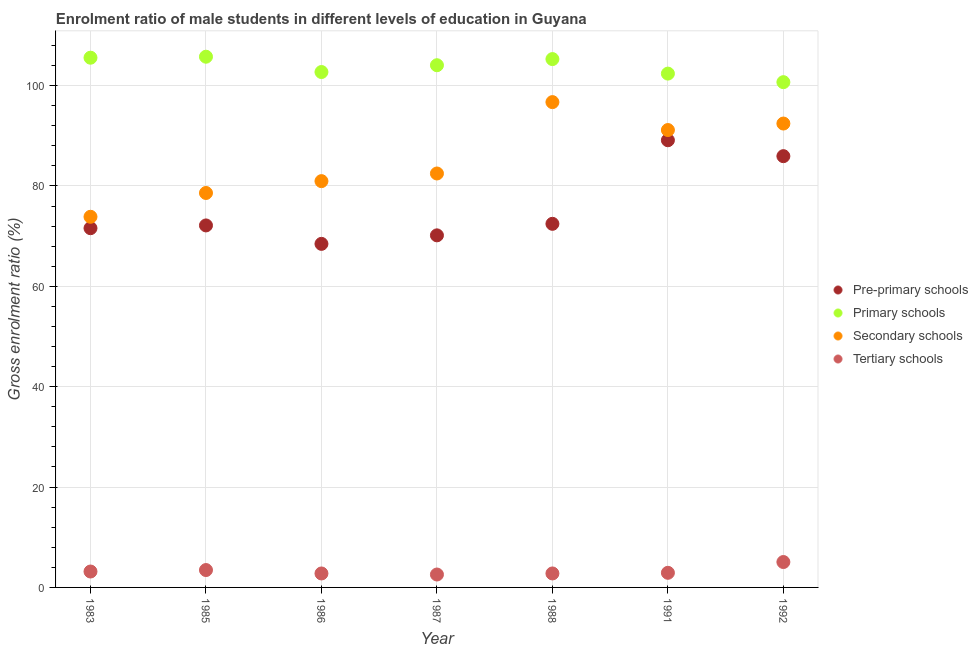What is the gross enrolment ratio(female) in secondary schools in 1983?
Give a very brief answer. 73.86. Across all years, what is the maximum gross enrolment ratio(female) in pre-primary schools?
Ensure brevity in your answer.  89.11. Across all years, what is the minimum gross enrolment ratio(female) in pre-primary schools?
Offer a terse response. 68.46. In which year was the gross enrolment ratio(female) in primary schools minimum?
Offer a very short reply. 1992. What is the total gross enrolment ratio(female) in secondary schools in the graph?
Provide a succinct answer. 596.2. What is the difference between the gross enrolment ratio(female) in pre-primary schools in 1986 and that in 1991?
Provide a short and direct response. -20.65. What is the difference between the gross enrolment ratio(female) in secondary schools in 1983 and the gross enrolment ratio(female) in pre-primary schools in 1986?
Make the answer very short. 5.4. What is the average gross enrolment ratio(female) in primary schools per year?
Provide a succinct answer. 103.78. In the year 1986, what is the difference between the gross enrolment ratio(female) in tertiary schools and gross enrolment ratio(female) in pre-primary schools?
Give a very brief answer. -65.68. In how many years, is the gross enrolment ratio(female) in secondary schools greater than 60 %?
Your answer should be compact. 7. What is the ratio of the gross enrolment ratio(female) in secondary schools in 1991 to that in 1992?
Your response must be concise. 0.99. Is the gross enrolment ratio(female) in secondary schools in 1987 less than that in 1992?
Your answer should be very brief. Yes. What is the difference between the highest and the second highest gross enrolment ratio(female) in pre-primary schools?
Your answer should be very brief. 3.17. What is the difference between the highest and the lowest gross enrolment ratio(female) in tertiary schools?
Provide a short and direct response. 2.49. Is it the case that in every year, the sum of the gross enrolment ratio(female) in secondary schools and gross enrolment ratio(female) in tertiary schools is greater than the sum of gross enrolment ratio(female) in pre-primary schools and gross enrolment ratio(female) in primary schools?
Your answer should be very brief. Yes. Is it the case that in every year, the sum of the gross enrolment ratio(female) in pre-primary schools and gross enrolment ratio(female) in primary schools is greater than the gross enrolment ratio(female) in secondary schools?
Keep it short and to the point. Yes. Is the gross enrolment ratio(female) in tertiary schools strictly greater than the gross enrolment ratio(female) in primary schools over the years?
Make the answer very short. No. Is the gross enrolment ratio(female) in primary schools strictly less than the gross enrolment ratio(female) in secondary schools over the years?
Provide a short and direct response. No. Does the graph contain any zero values?
Ensure brevity in your answer.  No. Does the graph contain grids?
Your answer should be very brief. Yes. How are the legend labels stacked?
Your response must be concise. Vertical. What is the title of the graph?
Your answer should be very brief. Enrolment ratio of male students in different levels of education in Guyana. Does "France" appear as one of the legend labels in the graph?
Offer a very short reply. No. What is the label or title of the X-axis?
Provide a short and direct response. Year. What is the label or title of the Y-axis?
Offer a very short reply. Gross enrolment ratio (%). What is the Gross enrolment ratio (%) in Pre-primary schools in 1983?
Your answer should be very brief. 71.59. What is the Gross enrolment ratio (%) in Primary schools in 1983?
Your answer should be compact. 105.56. What is the Gross enrolment ratio (%) in Secondary schools in 1983?
Your answer should be compact. 73.86. What is the Gross enrolment ratio (%) of Tertiary schools in 1983?
Keep it short and to the point. 3.17. What is the Gross enrolment ratio (%) in Pre-primary schools in 1985?
Ensure brevity in your answer.  72.14. What is the Gross enrolment ratio (%) in Primary schools in 1985?
Your answer should be very brief. 105.76. What is the Gross enrolment ratio (%) in Secondary schools in 1985?
Provide a short and direct response. 78.6. What is the Gross enrolment ratio (%) of Tertiary schools in 1985?
Make the answer very short. 3.46. What is the Gross enrolment ratio (%) in Pre-primary schools in 1986?
Your answer should be compact. 68.46. What is the Gross enrolment ratio (%) of Primary schools in 1986?
Ensure brevity in your answer.  102.7. What is the Gross enrolment ratio (%) of Secondary schools in 1986?
Provide a succinct answer. 80.96. What is the Gross enrolment ratio (%) of Tertiary schools in 1986?
Keep it short and to the point. 2.78. What is the Gross enrolment ratio (%) in Pre-primary schools in 1987?
Make the answer very short. 70.16. What is the Gross enrolment ratio (%) of Primary schools in 1987?
Your response must be concise. 104.06. What is the Gross enrolment ratio (%) in Secondary schools in 1987?
Provide a succinct answer. 82.49. What is the Gross enrolment ratio (%) in Tertiary schools in 1987?
Offer a very short reply. 2.57. What is the Gross enrolment ratio (%) of Pre-primary schools in 1988?
Provide a succinct answer. 72.46. What is the Gross enrolment ratio (%) of Primary schools in 1988?
Provide a short and direct response. 105.28. What is the Gross enrolment ratio (%) in Secondary schools in 1988?
Ensure brevity in your answer.  96.71. What is the Gross enrolment ratio (%) of Tertiary schools in 1988?
Offer a terse response. 2.79. What is the Gross enrolment ratio (%) of Pre-primary schools in 1991?
Your answer should be compact. 89.11. What is the Gross enrolment ratio (%) of Primary schools in 1991?
Your answer should be very brief. 102.39. What is the Gross enrolment ratio (%) in Secondary schools in 1991?
Provide a short and direct response. 91.15. What is the Gross enrolment ratio (%) of Tertiary schools in 1991?
Offer a terse response. 2.91. What is the Gross enrolment ratio (%) of Pre-primary schools in 1992?
Provide a succinct answer. 85.94. What is the Gross enrolment ratio (%) of Primary schools in 1992?
Offer a very short reply. 100.68. What is the Gross enrolment ratio (%) in Secondary schools in 1992?
Ensure brevity in your answer.  92.44. What is the Gross enrolment ratio (%) in Tertiary schools in 1992?
Your response must be concise. 5.06. Across all years, what is the maximum Gross enrolment ratio (%) in Pre-primary schools?
Your answer should be compact. 89.11. Across all years, what is the maximum Gross enrolment ratio (%) of Primary schools?
Offer a terse response. 105.76. Across all years, what is the maximum Gross enrolment ratio (%) in Secondary schools?
Your response must be concise. 96.71. Across all years, what is the maximum Gross enrolment ratio (%) in Tertiary schools?
Provide a succinct answer. 5.06. Across all years, what is the minimum Gross enrolment ratio (%) in Pre-primary schools?
Make the answer very short. 68.46. Across all years, what is the minimum Gross enrolment ratio (%) of Primary schools?
Your response must be concise. 100.68. Across all years, what is the minimum Gross enrolment ratio (%) in Secondary schools?
Offer a terse response. 73.86. Across all years, what is the minimum Gross enrolment ratio (%) of Tertiary schools?
Your answer should be very brief. 2.57. What is the total Gross enrolment ratio (%) in Pre-primary schools in the graph?
Keep it short and to the point. 529.85. What is the total Gross enrolment ratio (%) in Primary schools in the graph?
Ensure brevity in your answer.  726.43. What is the total Gross enrolment ratio (%) of Secondary schools in the graph?
Offer a very short reply. 596.2. What is the total Gross enrolment ratio (%) of Tertiary schools in the graph?
Offer a very short reply. 22.75. What is the difference between the Gross enrolment ratio (%) of Pre-primary schools in 1983 and that in 1985?
Your answer should be compact. -0.55. What is the difference between the Gross enrolment ratio (%) of Primary schools in 1983 and that in 1985?
Your answer should be very brief. -0.2. What is the difference between the Gross enrolment ratio (%) in Secondary schools in 1983 and that in 1985?
Your answer should be compact. -4.74. What is the difference between the Gross enrolment ratio (%) in Tertiary schools in 1983 and that in 1985?
Offer a very short reply. -0.29. What is the difference between the Gross enrolment ratio (%) of Pre-primary schools in 1983 and that in 1986?
Provide a short and direct response. 3.12. What is the difference between the Gross enrolment ratio (%) of Primary schools in 1983 and that in 1986?
Your answer should be compact. 2.85. What is the difference between the Gross enrolment ratio (%) of Secondary schools in 1983 and that in 1986?
Your response must be concise. -7.1. What is the difference between the Gross enrolment ratio (%) of Tertiary schools in 1983 and that in 1986?
Give a very brief answer. 0.39. What is the difference between the Gross enrolment ratio (%) of Pre-primary schools in 1983 and that in 1987?
Offer a terse response. 1.43. What is the difference between the Gross enrolment ratio (%) of Primary schools in 1983 and that in 1987?
Offer a terse response. 1.5. What is the difference between the Gross enrolment ratio (%) in Secondary schools in 1983 and that in 1987?
Keep it short and to the point. -8.63. What is the difference between the Gross enrolment ratio (%) of Tertiary schools in 1983 and that in 1987?
Keep it short and to the point. 0.6. What is the difference between the Gross enrolment ratio (%) in Pre-primary schools in 1983 and that in 1988?
Give a very brief answer. -0.87. What is the difference between the Gross enrolment ratio (%) in Primary schools in 1983 and that in 1988?
Keep it short and to the point. 0.27. What is the difference between the Gross enrolment ratio (%) in Secondary schools in 1983 and that in 1988?
Keep it short and to the point. -22.85. What is the difference between the Gross enrolment ratio (%) in Tertiary schools in 1983 and that in 1988?
Provide a succinct answer. 0.38. What is the difference between the Gross enrolment ratio (%) in Pre-primary schools in 1983 and that in 1991?
Offer a very short reply. -17.52. What is the difference between the Gross enrolment ratio (%) in Primary schools in 1983 and that in 1991?
Keep it short and to the point. 3.17. What is the difference between the Gross enrolment ratio (%) in Secondary schools in 1983 and that in 1991?
Make the answer very short. -17.29. What is the difference between the Gross enrolment ratio (%) of Tertiary schools in 1983 and that in 1991?
Ensure brevity in your answer.  0.26. What is the difference between the Gross enrolment ratio (%) of Pre-primary schools in 1983 and that in 1992?
Your answer should be very brief. -14.35. What is the difference between the Gross enrolment ratio (%) in Primary schools in 1983 and that in 1992?
Give a very brief answer. 4.87. What is the difference between the Gross enrolment ratio (%) in Secondary schools in 1983 and that in 1992?
Provide a short and direct response. -18.58. What is the difference between the Gross enrolment ratio (%) in Tertiary schools in 1983 and that in 1992?
Your answer should be very brief. -1.89. What is the difference between the Gross enrolment ratio (%) in Pre-primary schools in 1985 and that in 1986?
Keep it short and to the point. 3.67. What is the difference between the Gross enrolment ratio (%) of Primary schools in 1985 and that in 1986?
Your answer should be compact. 3.05. What is the difference between the Gross enrolment ratio (%) in Secondary schools in 1985 and that in 1986?
Offer a terse response. -2.36. What is the difference between the Gross enrolment ratio (%) in Tertiary schools in 1985 and that in 1986?
Make the answer very short. 0.68. What is the difference between the Gross enrolment ratio (%) of Pre-primary schools in 1985 and that in 1987?
Your response must be concise. 1.98. What is the difference between the Gross enrolment ratio (%) in Primary schools in 1985 and that in 1987?
Offer a terse response. 1.7. What is the difference between the Gross enrolment ratio (%) in Secondary schools in 1985 and that in 1987?
Your answer should be compact. -3.88. What is the difference between the Gross enrolment ratio (%) in Tertiary schools in 1985 and that in 1987?
Your answer should be very brief. 0.89. What is the difference between the Gross enrolment ratio (%) in Pre-primary schools in 1985 and that in 1988?
Your answer should be very brief. -0.32. What is the difference between the Gross enrolment ratio (%) in Primary schools in 1985 and that in 1988?
Your answer should be compact. 0.47. What is the difference between the Gross enrolment ratio (%) in Secondary schools in 1985 and that in 1988?
Make the answer very short. -18.11. What is the difference between the Gross enrolment ratio (%) of Tertiary schools in 1985 and that in 1988?
Keep it short and to the point. 0.68. What is the difference between the Gross enrolment ratio (%) of Pre-primary schools in 1985 and that in 1991?
Give a very brief answer. -16.97. What is the difference between the Gross enrolment ratio (%) of Primary schools in 1985 and that in 1991?
Offer a very short reply. 3.37. What is the difference between the Gross enrolment ratio (%) in Secondary schools in 1985 and that in 1991?
Give a very brief answer. -12.54. What is the difference between the Gross enrolment ratio (%) in Tertiary schools in 1985 and that in 1991?
Your answer should be compact. 0.55. What is the difference between the Gross enrolment ratio (%) in Pre-primary schools in 1985 and that in 1992?
Your answer should be very brief. -13.8. What is the difference between the Gross enrolment ratio (%) in Primary schools in 1985 and that in 1992?
Your answer should be very brief. 5.07. What is the difference between the Gross enrolment ratio (%) of Secondary schools in 1985 and that in 1992?
Offer a terse response. -13.84. What is the difference between the Gross enrolment ratio (%) of Tertiary schools in 1985 and that in 1992?
Your answer should be compact. -1.6. What is the difference between the Gross enrolment ratio (%) of Pre-primary schools in 1986 and that in 1987?
Provide a succinct answer. -1.7. What is the difference between the Gross enrolment ratio (%) of Primary schools in 1986 and that in 1987?
Offer a terse response. -1.36. What is the difference between the Gross enrolment ratio (%) of Secondary schools in 1986 and that in 1987?
Make the answer very short. -1.52. What is the difference between the Gross enrolment ratio (%) in Tertiary schools in 1986 and that in 1987?
Offer a very short reply. 0.21. What is the difference between the Gross enrolment ratio (%) of Pre-primary schools in 1986 and that in 1988?
Give a very brief answer. -3.99. What is the difference between the Gross enrolment ratio (%) of Primary schools in 1986 and that in 1988?
Your answer should be compact. -2.58. What is the difference between the Gross enrolment ratio (%) of Secondary schools in 1986 and that in 1988?
Give a very brief answer. -15.75. What is the difference between the Gross enrolment ratio (%) in Tertiary schools in 1986 and that in 1988?
Provide a short and direct response. -0. What is the difference between the Gross enrolment ratio (%) of Pre-primary schools in 1986 and that in 1991?
Offer a terse response. -20.65. What is the difference between the Gross enrolment ratio (%) of Primary schools in 1986 and that in 1991?
Provide a succinct answer. 0.31. What is the difference between the Gross enrolment ratio (%) of Secondary schools in 1986 and that in 1991?
Offer a terse response. -10.18. What is the difference between the Gross enrolment ratio (%) in Tertiary schools in 1986 and that in 1991?
Offer a very short reply. -0.13. What is the difference between the Gross enrolment ratio (%) of Pre-primary schools in 1986 and that in 1992?
Your answer should be very brief. -17.48. What is the difference between the Gross enrolment ratio (%) in Primary schools in 1986 and that in 1992?
Keep it short and to the point. 2.02. What is the difference between the Gross enrolment ratio (%) in Secondary schools in 1986 and that in 1992?
Your answer should be compact. -11.48. What is the difference between the Gross enrolment ratio (%) in Tertiary schools in 1986 and that in 1992?
Keep it short and to the point. -2.28. What is the difference between the Gross enrolment ratio (%) in Pre-primary schools in 1987 and that in 1988?
Your response must be concise. -2.3. What is the difference between the Gross enrolment ratio (%) of Primary schools in 1987 and that in 1988?
Keep it short and to the point. -1.22. What is the difference between the Gross enrolment ratio (%) of Secondary schools in 1987 and that in 1988?
Give a very brief answer. -14.22. What is the difference between the Gross enrolment ratio (%) of Tertiary schools in 1987 and that in 1988?
Give a very brief answer. -0.21. What is the difference between the Gross enrolment ratio (%) of Pre-primary schools in 1987 and that in 1991?
Ensure brevity in your answer.  -18.95. What is the difference between the Gross enrolment ratio (%) in Primary schools in 1987 and that in 1991?
Make the answer very short. 1.67. What is the difference between the Gross enrolment ratio (%) in Secondary schools in 1987 and that in 1991?
Your answer should be compact. -8.66. What is the difference between the Gross enrolment ratio (%) of Tertiary schools in 1987 and that in 1991?
Offer a terse response. -0.34. What is the difference between the Gross enrolment ratio (%) of Pre-primary schools in 1987 and that in 1992?
Your answer should be compact. -15.78. What is the difference between the Gross enrolment ratio (%) in Primary schools in 1987 and that in 1992?
Offer a terse response. 3.38. What is the difference between the Gross enrolment ratio (%) of Secondary schools in 1987 and that in 1992?
Offer a very short reply. -9.95. What is the difference between the Gross enrolment ratio (%) of Tertiary schools in 1987 and that in 1992?
Offer a very short reply. -2.49. What is the difference between the Gross enrolment ratio (%) of Pre-primary schools in 1988 and that in 1991?
Your answer should be compact. -16.65. What is the difference between the Gross enrolment ratio (%) in Primary schools in 1988 and that in 1991?
Keep it short and to the point. 2.89. What is the difference between the Gross enrolment ratio (%) in Secondary schools in 1988 and that in 1991?
Keep it short and to the point. 5.56. What is the difference between the Gross enrolment ratio (%) in Tertiary schools in 1988 and that in 1991?
Offer a terse response. -0.13. What is the difference between the Gross enrolment ratio (%) of Pre-primary schools in 1988 and that in 1992?
Ensure brevity in your answer.  -13.48. What is the difference between the Gross enrolment ratio (%) of Primary schools in 1988 and that in 1992?
Offer a very short reply. 4.6. What is the difference between the Gross enrolment ratio (%) in Secondary schools in 1988 and that in 1992?
Your response must be concise. 4.27. What is the difference between the Gross enrolment ratio (%) of Tertiary schools in 1988 and that in 1992?
Ensure brevity in your answer.  -2.28. What is the difference between the Gross enrolment ratio (%) in Pre-primary schools in 1991 and that in 1992?
Provide a short and direct response. 3.17. What is the difference between the Gross enrolment ratio (%) in Primary schools in 1991 and that in 1992?
Offer a very short reply. 1.71. What is the difference between the Gross enrolment ratio (%) in Secondary schools in 1991 and that in 1992?
Offer a terse response. -1.29. What is the difference between the Gross enrolment ratio (%) of Tertiary schools in 1991 and that in 1992?
Your answer should be very brief. -2.15. What is the difference between the Gross enrolment ratio (%) in Pre-primary schools in 1983 and the Gross enrolment ratio (%) in Primary schools in 1985?
Provide a short and direct response. -34.17. What is the difference between the Gross enrolment ratio (%) in Pre-primary schools in 1983 and the Gross enrolment ratio (%) in Secondary schools in 1985?
Give a very brief answer. -7.02. What is the difference between the Gross enrolment ratio (%) in Pre-primary schools in 1983 and the Gross enrolment ratio (%) in Tertiary schools in 1985?
Give a very brief answer. 68.12. What is the difference between the Gross enrolment ratio (%) of Primary schools in 1983 and the Gross enrolment ratio (%) of Secondary schools in 1985?
Ensure brevity in your answer.  26.96. What is the difference between the Gross enrolment ratio (%) in Primary schools in 1983 and the Gross enrolment ratio (%) in Tertiary schools in 1985?
Keep it short and to the point. 102.09. What is the difference between the Gross enrolment ratio (%) in Secondary schools in 1983 and the Gross enrolment ratio (%) in Tertiary schools in 1985?
Give a very brief answer. 70.39. What is the difference between the Gross enrolment ratio (%) in Pre-primary schools in 1983 and the Gross enrolment ratio (%) in Primary schools in 1986?
Ensure brevity in your answer.  -31.12. What is the difference between the Gross enrolment ratio (%) of Pre-primary schools in 1983 and the Gross enrolment ratio (%) of Secondary schools in 1986?
Provide a succinct answer. -9.38. What is the difference between the Gross enrolment ratio (%) of Pre-primary schools in 1983 and the Gross enrolment ratio (%) of Tertiary schools in 1986?
Give a very brief answer. 68.8. What is the difference between the Gross enrolment ratio (%) of Primary schools in 1983 and the Gross enrolment ratio (%) of Secondary schools in 1986?
Your answer should be compact. 24.6. What is the difference between the Gross enrolment ratio (%) in Primary schools in 1983 and the Gross enrolment ratio (%) in Tertiary schools in 1986?
Your answer should be very brief. 102.78. What is the difference between the Gross enrolment ratio (%) of Secondary schools in 1983 and the Gross enrolment ratio (%) of Tertiary schools in 1986?
Make the answer very short. 71.08. What is the difference between the Gross enrolment ratio (%) of Pre-primary schools in 1983 and the Gross enrolment ratio (%) of Primary schools in 1987?
Offer a terse response. -32.47. What is the difference between the Gross enrolment ratio (%) in Pre-primary schools in 1983 and the Gross enrolment ratio (%) in Secondary schools in 1987?
Your answer should be compact. -10.9. What is the difference between the Gross enrolment ratio (%) of Pre-primary schools in 1983 and the Gross enrolment ratio (%) of Tertiary schools in 1987?
Provide a succinct answer. 69.01. What is the difference between the Gross enrolment ratio (%) of Primary schools in 1983 and the Gross enrolment ratio (%) of Secondary schools in 1987?
Your answer should be very brief. 23.07. What is the difference between the Gross enrolment ratio (%) in Primary schools in 1983 and the Gross enrolment ratio (%) in Tertiary schools in 1987?
Your answer should be very brief. 102.98. What is the difference between the Gross enrolment ratio (%) in Secondary schools in 1983 and the Gross enrolment ratio (%) in Tertiary schools in 1987?
Offer a terse response. 71.28. What is the difference between the Gross enrolment ratio (%) of Pre-primary schools in 1983 and the Gross enrolment ratio (%) of Primary schools in 1988?
Offer a very short reply. -33.7. What is the difference between the Gross enrolment ratio (%) of Pre-primary schools in 1983 and the Gross enrolment ratio (%) of Secondary schools in 1988?
Make the answer very short. -25.12. What is the difference between the Gross enrolment ratio (%) in Pre-primary schools in 1983 and the Gross enrolment ratio (%) in Tertiary schools in 1988?
Your answer should be compact. 68.8. What is the difference between the Gross enrolment ratio (%) in Primary schools in 1983 and the Gross enrolment ratio (%) in Secondary schools in 1988?
Offer a terse response. 8.85. What is the difference between the Gross enrolment ratio (%) of Primary schools in 1983 and the Gross enrolment ratio (%) of Tertiary schools in 1988?
Provide a succinct answer. 102.77. What is the difference between the Gross enrolment ratio (%) of Secondary schools in 1983 and the Gross enrolment ratio (%) of Tertiary schools in 1988?
Keep it short and to the point. 71.07. What is the difference between the Gross enrolment ratio (%) in Pre-primary schools in 1983 and the Gross enrolment ratio (%) in Primary schools in 1991?
Keep it short and to the point. -30.8. What is the difference between the Gross enrolment ratio (%) in Pre-primary schools in 1983 and the Gross enrolment ratio (%) in Secondary schools in 1991?
Make the answer very short. -19.56. What is the difference between the Gross enrolment ratio (%) in Pre-primary schools in 1983 and the Gross enrolment ratio (%) in Tertiary schools in 1991?
Ensure brevity in your answer.  68.67. What is the difference between the Gross enrolment ratio (%) in Primary schools in 1983 and the Gross enrolment ratio (%) in Secondary schools in 1991?
Provide a succinct answer. 14.41. What is the difference between the Gross enrolment ratio (%) in Primary schools in 1983 and the Gross enrolment ratio (%) in Tertiary schools in 1991?
Provide a succinct answer. 102.64. What is the difference between the Gross enrolment ratio (%) of Secondary schools in 1983 and the Gross enrolment ratio (%) of Tertiary schools in 1991?
Offer a terse response. 70.94. What is the difference between the Gross enrolment ratio (%) of Pre-primary schools in 1983 and the Gross enrolment ratio (%) of Primary schools in 1992?
Your response must be concise. -29.1. What is the difference between the Gross enrolment ratio (%) of Pre-primary schools in 1983 and the Gross enrolment ratio (%) of Secondary schools in 1992?
Offer a terse response. -20.85. What is the difference between the Gross enrolment ratio (%) of Pre-primary schools in 1983 and the Gross enrolment ratio (%) of Tertiary schools in 1992?
Your response must be concise. 66.53. What is the difference between the Gross enrolment ratio (%) in Primary schools in 1983 and the Gross enrolment ratio (%) in Secondary schools in 1992?
Your response must be concise. 13.12. What is the difference between the Gross enrolment ratio (%) of Primary schools in 1983 and the Gross enrolment ratio (%) of Tertiary schools in 1992?
Offer a very short reply. 100.5. What is the difference between the Gross enrolment ratio (%) in Secondary schools in 1983 and the Gross enrolment ratio (%) in Tertiary schools in 1992?
Your response must be concise. 68.8. What is the difference between the Gross enrolment ratio (%) in Pre-primary schools in 1985 and the Gross enrolment ratio (%) in Primary schools in 1986?
Offer a very short reply. -30.57. What is the difference between the Gross enrolment ratio (%) in Pre-primary schools in 1985 and the Gross enrolment ratio (%) in Secondary schools in 1986?
Provide a succinct answer. -8.83. What is the difference between the Gross enrolment ratio (%) in Pre-primary schools in 1985 and the Gross enrolment ratio (%) in Tertiary schools in 1986?
Offer a very short reply. 69.35. What is the difference between the Gross enrolment ratio (%) of Primary schools in 1985 and the Gross enrolment ratio (%) of Secondary schools in 1986?
Your response must be concise. 24.79. What is the difference between the Gross enrolment ratio (%) of Primary schools in 1985 and the Gross enrolment ratio (%) of Tertiary schools in 1986?
Ensure brevity in your answer.  102.97. What is the difference between the Gross enrolment ratio (%) in Secondary schools in 1985 and the Gross enrolment ratio (%) in Tertiary schools in 1986?
Ensure brevity in your answer.  75.82. What is the difference between the Gross enrolment ratio (%) in Pre-primary schools in 1985 and the Gross enrolment ratio (%) in Primary schools in 1987?
Provide a short and direct response. -31.92. What is the difference between the Gross enrolment ratio (%) of Pre-primary schools in 1985 and the Gross enrolment ratio (%) of Secondary schools in 1987?
Your answer should be very brief. -10.35. What is the difference between the Gross enrolment ratio (%) of Pre-primary schools in 1985 and the Gross enrolment ratio (%) of Tertiary schools in 1987?
Offer a terse response. 69.56. What is the difference between the Gross enrolment ratio (%) in Primary schools in 1985 and the Gross enrolment ratio (%) in Secondary schools in 1987?
Give a very brief answer. 23.27. What is the difference between the Gross enrolment ratio (%) in Primary schools in 1985 and the Gross enrolment ratio (%) in Tertiary schools in 1987?
Offer a terse response. 103.18. What is the difference between the Gross enrolment ratio (%) in Secondary schools in 1985 and the Gross enrolment ratio (%) in Tertiary schools in 1987?
Make the answer very short. 76.03. What is the difference between the Gross enrolment ratio (%) in Pre-primary schools in 1985 and the Gross enrolment ratio (%) in Primary schools in 1988?
Offer a terse response. -33.15. What is the difference between the Gross enrolment ratio (%) of Pre-primary schools in 1985 and the Gross enrolment ratio (%) of Secondary schools in 1988?
Offer a very short reply. -24.57. What is the difference between the Gross enrolment ratio (%) of Pre-primary schools in 1985 and the Gross enrolment ratio (%) of Tertiary schools in 1988?
Provide a short and direct response. 69.35. What is the difference between the Gross enrolment ratio (%) of Primary schools in 1985 and the Gross enrolment ratio (%) of Secondary schools in 1988?
Give a very brief answer. 9.05. What is the difference between the Gross enrolment ratio (%) of Primary schools in 1985 and the Gross enrolment ratio (%) of Tertiary schools in 1988?
Give a very brief answer. 102.97. What is the difference between the Gross enrolment ratio (%) in Secondary schools in 1985 and the Gross enrolment ratio (%) in Tertiary schools in 1988?
Your answer should be compact. 75.82. What is the difference between the Gross enrolment ratio (%) in Pre-primary schools in 1985 and the Gross enrolment ratio (%) in Primary schools in 1991?
Ensure brevity in your answer.  -30.25. What is the difference between the Gross enrolment ratio (%) in Pre-primary schools in 1985 and the Gross enrolment ratio (%) in Secondary schools in 1991?
Keep it short and to the point. -19.01. What is the difference between the Gross enrolment ratio (%) in Pre-primary schools in 1985 and the Gross enrolment ratio (%) in Tertiary schools in 1991?
Give a very brief answer. 69.22. What is the difference between the Gross enrolment ratio (%) in Primary schools in 1985 and the Gross enrolment ratio (%) in Secondary schools in 1991?
Provide a short and direct response. 14.61. What is the difference between the Gross enrolment ratio (%) of Primary schools in 1985 and the Gross enrolment ratio (%) of Tertiary schools in 1991?
Offer a terse response. 102.84. What is the difference between the Gross enrolment ratio (%) in Secondary schools in 1985 and the Gross enrolment ratio (%) in Tertiary schools in 1991?
Your response must be concise. 75.69. What is the difference between the Gross enrolment ratio (%) of Pre-primary schools in 1985 and the Gross enrolment ratio (%) of Primary schools in 1992?
Your answer should be compact. -28.55. What is the difference between the Gross enrolment ratio (%) of Pre-primary schools in 1985 and the Gross enrolment ratio (%) of Secondary schools in 1992?
Provide a succinct answer. -20.3. What is the difference between the Gross enrolment ratio (%) in Pre-primary schools in 1985 and the Gross enrolment ratio (%) in Tertiary schools in 1992?
Offer a terse response. 67.07. What is the difference between the Gross enrolment ratio (%) of Primary schools in 1985 and the Gross enrolment ratio (%) of Secondary schools in 1992?
Make the answer very short. 13.32. What is the difference between the Gross enrolment ratio (%) in Primary schools in 1985 and the Gross enrolment ratio (%) in Tertiary schools in 1992?
Your answer should be compact. 100.69. What is the difference between the Gross enrolment ratio (%) in Secondary schools in 1985 and the Gross enrolment ratio (%) in Tertiary schools in 1992?
Keep it short and to the point. 73.54. What is the difference between the Gross enrolment ratio (%) of Pre-primary schools in 1986 and the Gross enrolment ratio (%) of Primary schools in 1987?
Provide a short and direct response. -35.6. What is the difference between the Gross enrolment ratio (%) in Pre-primary schools in 1986 and the Gross enrolment ratio (%) in Secondary schools in 1987?
Offer a terse response. -14.02. What is the difference between the Gross enrolment ratio (%) of Pre-primary schools in 1986 and the Gross enrolment ratio (%) of Tertiary schools in 1987?
Offer a terse response. 65.89. What is the difference between the Gross enrolment ratio (%) of Primary schools in 1986 and the Gross enrolment ratio (%) of Secondary schools in 1987?
Provide a short and direct response. 20.22. What is the difference between the Gross enrolment ratio (%) in Primary schools in 1986 and the Gross enrolment ratio (%) in Tertiary schools in 1987?
Your response must be concise. 100.13. What is the difference between the Gross enrolment ratio (%) in Secondary schools in 1986 and the Gross enrolment ratio (%) in Tertiary schools in 1987?
Provide a succinct answer. 78.39. What is the difference between the Gross enrolment ratio (%) in Pre-primary schools in 1986 and the Gross enrolment ratio (%) in Primary schools in 1988?
Keep it short and to the point. -36.82. What is the difference between the Gross enrolment ratio (%) in Pre-primary schools in 1986 and the Gross enrolment ratio (%) in Secondary schools in 1988?
Keep it short and to the point. -28.25. What is the difference between the Gross enrolment ratio (%) of Pre-primary schools in 1986 and the Gross enrolment ratio (%) of Tertiary schools in 1988?
Provide a succinct answer. 65.68. What is the difference between the Gross enrolment ratio (%) of Primary schools in 1986 and the Gross enrolment ratio (%) of Secondary schools in 1988?
Provide a short and direct response. 5.99. What is the difference between the Gross enrolment ratio (%) of Primary schools in 1986 and the Gross enrolment ratio (%) of Tertiary schools in 1988?
Your answer should be very brief. 99.92. What is the difference between the Gross enrolment ratio (%) of Secondary schools in 1986 and the Gross enrolment ratio (%) of Tertiary schools in 1988?
Your response must be concise. 78.18. What is the difference between the Gross enrolment ratio (%) of Pre-primary schools in 1986 and the Gross enrolment ratio (%) of Primary schools in 1991?
Provide a succinct answer. -33.93. What is the difference between the Gross enrolment ratio (%) in Pre-primary schools in 1986 and the Gross enrolment ratio (%) in Secondary schools in 1991?
Keep it short and to the point. -22.68. What is the difference between the Gross enrolment ratio (%) in Pre-primary schools in 1986 and the Gross enrolment ratio (%) in Tertiary schools in 1991?
Offer a very short reply. 65.55. What is the difference between the Gross enrolment ratio (%) in Primary schools in 1986 and the Gross enrolment ratio (%) in Secondary schools in 1991?
Your response must be concise. 11.56. What is the difference between the Gross enrolment ratio (%) of Primary schools in 1986 and the Gross enrolment ratio (%) of Tertiary schools in 1991?
Ensure brevity in your answer.  99.79. What is the difference between the Gross enrolment ratio (%) of Secondary schools in 1986 and the Gross enrolment ratio (%) of Tertiary schools in 1991?
Make the answer very short. 78.05. What is the difference between the Gross enrolment ratio (%) in Pre-primary schools in 1986 and the Gross enrolment ratio (%) in Primary schools in 1992?
Offer a terse response. -32.22. What is the difference between the Gross enrolment ratio (%) in Pre-primary schools in 1986 and the Gross enrolment ratio (%) in Secondary schools in 1992?
Offer a very short reply. -23.98. What is the difference between the Gross enrolment ratio (%) of Pre-primary schools in 1986 and the Gross enrolment ratio (%) of Tertiary schools in 1992?
Make the answer very short. 63.4. What is the difference between the Gross enrolment ratio (%) of Primary schools in 1986 and the Gross enrolment ratio (%) of Secondary schools in 1992?
Offer a terse response. 10.26. What is the difference between the Gross enrolment ratio (%) in Primary schools in 1986 and the Gross enrolment ratio (%) in Tertiary schools in 1992?
Make the answer very short. 97.64. What is the difference between the Gross enrolment ratio (%) of Secondary schools in 1986 and the Gross enrolment ratio (%) of Tertiary schools in 1992?
Make the answer very short. 75.9. What is the difference between the Gross enrolment ratio (%) in Pre-primary schools in 1987 and the Gross enrolment ratio (%) in Primary schools in 1988?
Give a very brief answer. -35.13. What is the difference between the Gross enrolment ratio (%) of Pre-primary schools in 1987 and the Gross enrolment ratio (%) of Secondary schools in 1988?
Your answer should be very brief. -26.55. What is the difference between the Gross enrolment ratio (%) in Pre-primary schools in 1987 and the Gross enrolment ratio (%) in Tertiary schools in 1988?
Offer a terse response. 67.37. What is the difference between the Gross enrolment ratio (%) of Primary schools in 1987 and the Gross enrolment ratio (%) of Secondary schools in 1988?
Provide a short and direct response. 7.35. What is the difference between the Gross enrolment ratio (%) of Primary schools in 1987 and the Gross enrolment ratio (%) of Tertiary schools in 1988?
Give a very brief answer. 101.27. What is the difference between the Gross enrolment ratio (%) in Secondary schools in 1987 and the Gross enrolment ratio (%) in Tertiary schools in 1988?
Provide a short and direct response. 79.7. What is the difference between the Gross enrolment ratio (%) in Pre-primary schools in 1987 and the Gross enrolment ratio (%) in Primary schools in 1991?
Offer a terse response. -32.23. What is the difference between the Gross enrolment ratio (%) in Pre-primary schools in 1987 and the Gross enrolment ratio (%) in Secondary schools in 1991?
Provide a succinct answer. -20.99. What is the difference between the Gross enrolment ratio (%) in Pre-primary schools in 1987 and the Gross enrolment ratio (%) in Tertiary schools in 1991?
Offer a very short reply. 67.24. What is the difference between the Gross enrolment ratio (%) in Primary schools in 1987 and the Gross enrolment ratio (%) in Secondary schools in 1991?
Keep it short and to the point. 12.91. What is the difference between the Gross enrolment ratio (%) of Primary schools in 1987 and the Gross enrolment ratio (%) of Tertiary schools in 1991?
Your response must be concise. 101.15. What is the difference between the Gross enrolment ratio (%) in Secondary schools in 1987 and the Gross enrolment ratio (%) in Tertiary schools in 1991?
Your answer should be very brief. 79.57. What is the difference between the Gross enrolment ratio (%) of Pre-primary schools in 1987 and the Gross enrolment ratio (%) of Primary schools in 1992?
Your answer should be compact. -30.53. What is the difference between the Gross enrolment ratio (%) in Pre-primary schools in 1987 and the Gross enrolment ratio (%) in Secondary schools in 1992?
Provide a short and direct response. -22.28. What is the difference between the Gross enrolment ratio (%) in Pre-primary schools in 1987 and the Gross enrolment ratio (%) in Tertiary schools in 1992?
Provide a succinct answer. 65.1. What is the difference between the Gross enrolment ratio (%) of Primary schools in 1987 and the Gross enrolment ratio (%) of Secondary schools in 1992?
Offer a terse response. 11.62. What is the difference between the Gross enrolment ratio (%) in Primary schools in 1987 and the Gross enrolment ratio (%) in Tertiary schools in 1992?
Provide a succinct answer. 99. What is the difference between the Gross enrolment ratio (%) in Secondary schools in 1987 and the Gross enrolment ratio (%) in Tertiary schools in 1992?
Your answer should be very brief. 77.42. What is the difference between the Gross enrolment ratio (%) in Pre-primary schools in 1988 and the Gross enrolment ratio (%) in Primary schools in 1991?
Give a very brief answer. -29.93. What is the difference between the Gross enrolment ratio (%) of Pre-primary schools in 1988 and the Gross enrolment ratio (%) of Secondary schools in 1991?
Make the answer very short. -18.69. What is the difference between the Gross enrolment ratio (%) in Pre-primary schools in 1988 and the Gross enrolment ratio (%) in Tertiary schools in 1991?
Your answer should be very brief. 69.54. What is the difference between the Gross enrolment ratio (%) in Primary schools in 1988 and the Gross enrolment ratio (%) in Secondary schools in 1991?
Provide a succinct answer. 14.14. What is the difference between the Gross enrolment ratio (%) of Primary schools in 1988 and the Gross enrolment ratio (%) of Tertiary schools in 1991?
Offer a very short reply. 102.37. What is the difference between the Gross enrolment ratio (%) of Secondary schools in 1988 and the Gross enrolment ratio (%) of Tertiary schools in 1991?
Provide a short and direct response. 93.8. What is the difference between the Gross enrolment ratio (%) in Pre-primary schools in 1988 and the Gross enrolment ratio (%) in Primary schools in 1992?
Keep it short and to the point. -28.23. What is the difference between the Gross enrolment ratio (%) in Pre-primary schools in 1988 and the Gross enrolment ratio (%) in Secondary schools in 1992?
Keep it short and to the point. -19.98. What is the difference between the Gross enrolment ratio (%) in Pre-primary schools in 1988 and the Gross enrolment ratio (%) in Tertiary schools in 1992?
Your answer should be very brief. 67.4. What is the difference between the Gross enrolment ratio (%) of Primary schools in 1988 and the Gross enrolment ratio (%) of Secondary schools in 1992?
Your response must be concise. 12.84. What is the difference between the Gross enrolment ratio (%) in Primary schools in 1988 and the Gross enrolment ratio (%) in Tertiary schools in 1992?
Give a very brief answer. 100.22. What is the difference between the Gross enrolment ratio (%) of Secondary schools in 1988 and the Gross enrolment ratio (%) of Tertiary schools in 1992?
Ensure brevity in your answer.  91.65. What is the difference between the Gross enrolment ratio (%) in Pre-primary schools in 1991 and the Gross enrolment ratio (%) in Primary schools in 1992?
Keep it short and to the point. -11.57. What is the difference between the Gross enrolment ratio (%) in Pre-primary schools in 1991 and the Gross enrolment ratio (%) in Secondary schools in 1992?
Offer a very short reply. -3.33. What is the difference between the Gross enrolment ratio (%) of Pre-primary schools in 1991 and the Gross enrolment ratio (%) of Tertiary schools in 1992?
Your response must be concise. 84.05. What is the difference between the Gross enrolment ratio (%) of Primary schools in 1991 and the Gross enrolment ratio (%) of Secondary schools in 1992?
Keep it short and to the point. 9.95. What is the difference between the Gross enrolment ratio (%) in Primary schools in 1991 and the Gross enrolment ratio (%) in Tertiary schools in 1992?
Your response must be concise. 97.33. What is the difference between the Gross enrolment ratio (%) of Secondary schools in 1991 and the Gross enrolment ratio (%) of Tertiary schools in 1992?
Your answer should be compact. 86.08. What is the average Gross enrolment ratio (%) of Pre-primary schools per year?
Your answer should be very brief. 75.69. What is the average Gross enrolment ratio (%) of Primary schools per year?
Give a very brief answer. 103.78. What is the average Gross enrolment ratio (%) of Secondary schools per year?
Your answer should be very brief. 85.17. What is the average Gross enrolment ratio (%) in Tertiary schools per year?
Your response must be concise. 3.25. In the year 1983, what is the difference between the Gross enrolment ratio (%) in Pre-primary schools and Gross enrolment ratio (%) in Primary schools?
Provide a succinct answer. -33.97. In the year 1983, what is the difference between the Gross enrolment ratio (%) in Pre-primary schools and Gross enrolment ratio (%) in Secondary schools?
Your response must be concise. -2.27. In the year 1983, what is the difference between the Gross enrolment ratio (%) in Pre-primary schools and Gross enrolment ratio (%) in Tertiary schools?
Keep it short and to the point. 68.42. In the year 1983, what is the difference between the Gross enrolment ratio (%) in Primary schools and Gross enrolment ratio (%) in Secondary schools?
Make the answer very short. 31.7. In the year 1983, what is the difference between the Gross enrolment ratio (%) of Primary schools and Gross enrolment ratio (%) of Tertiary schools?
Provide a short and direct response. 102.39. In the year 1983, what is the difference between the Gross enrolment ratio (%) of Secondary schools and Gross enrolment ratio (%) of Tertiary schools?
Make the answer very short. 70.69. In the year 1985, what is the difference between the Gross enrolment ratio (%) in Pre-primary schools and Gross enrolment ratio (%) in Primary schools?
Offer a terse response. -33.62. In the year 1985, what is the difference between the Gross enrolment ratio (%) in Pre-primary schools and Gross enrolment ratio (%) in Secondary schools?
Keep it short and to the point. -6.47. In the year 1985, what is the difference between the Gross enrolment ratio (%) in Pre-primary schools and Gross enrolment ratio (%) in Tertiary schools?
Offer a terse response. 68.67. In the year 1985, what is the difference between the Gross enrolment ratio (%) in Primary schools and Gross enrolment ratio (%) in Secondary schools?
Make the answer very short. 27.15. In the year 1985, what is the difference between the Gross enrolment ratio (%) of Primary schools and Gross enrolment ratio (%) of Tertiary schools?
Make the answer very short. 102.29. In the year 1985, what is the difference between the Gross enrolment ratio (%) of Secondary schools and Gross enrolment ratio (%) of Tertiary schools?
Offer a very short reply. 75.14. In the year 1986, what is the difference between the Gross enrolment ratio (%) of Pre-primary schools and Gross enrolment ratio (%) of Primary schools?
Ensure brevity in your answer.  -34.24. In the year 1986, what is the difference between the Gross enrolment ratio (%) in Pre-primary schools and Gross enrolment ratio (%) in Secondary schools?
Offer a very short reply. -12.5. In the year 1986, what is the difference between the Gross enrolment ratio (%) in Pre-primary schools and Gross enrolment ratio (%) in Tertiary schools?
Provide a succinct answer. 65.68. In the year 1986, what is the difference between the Gross enrolment ratio (%) of Primary schools and Gross enrolment ratio (%) of Secondary schools?
Provide a succinct answer. 21.74. In the year 1986, what is the difference between the Gross enrolment ratio (%) in Primary schools and Gross enrolment ratio (%) in Tertiary schools?
Provide a succinct answer. 99.92. In the year 1986, what is the difference between the Gross enrolment ratio (%) in Secondary schools and Gross enrolment ratio (%) in Tertiary schools?
Offer a terse response. 78.18. In the year 1987, what is the difference between the Gross enrolment ratio (%) of Pre-primary schools and Gross enrolment ratio (%) of Primary schools?
Your answer should be very brief. -33.9. In the year 1987, what is the difference between the Gross enrolment ratio (%) of Pre-primary schools and Gross enrolment ratio (%) of Secondary schools?
Provide a succinct answer. -12.33. In the year 1987, what is the difference between the Gross enrolment ratio (%) of Pre-primary schools and Gross enrolment ratio (%) of Tertiary schools?
Your answer should be very brief. 67.58. In the year 1987, what is the difference between the Gross enrolment ratio (%) in Primary schools and Gross enrolment ratio (%) in Secondary schools?
Your response must be concise. 21.57. In the year 1987, what is the difference between the Gross enrolment ratio (%) in Primary schools and Gross enrolment ratio (%) in Tertiary schools?
Offer a terse response. 101.49. In the year 1987, what is the difference between the Gross enrolment ratio (%) in Secondary schools and Gross enrolment ratio (%) in Tertiary schools?
Your response must be concise. 79.91. In the year 1988, what is the difference between the Gross enrolment ratio (%) of Pre-primary schools and Gross enrolment ratio (%) of Primary schools?
Give a very brief answer. -32.83. In the year 1988, what is the difference between the Gross enrolment ratio (%) of Pre-primary schools and Gross enrolment ratio (%) of Secondary schools?
Make the answer very short. -24.25. In the year 1988, what is the difference between the Gross enrolment ratio (%) in Pre-primary schools and Gross enrolment ratio (%) in Tertiary schools?
Offer a very short reply. 69.67. In the year 1988, what is the difference between the Gross enrolment ratio (%) of Primary schools and Gross enrolment ratio (%) of Secondary schools?
Offer a very short reply. 8.57. In the year 1988, what is the difference between the Gross enrolment ratio (%) in Primary schools and Gross enrolment ratio (%) in Tertiary schools?
Ensure brevity in your answer.  102.5. In the year 1988, what is the difference between the Gross enrolment ratio (%) in Secondary schools and Gross enrolment ratio (%) in Tertiary schools?
Give a very brief answer. 93.92. In the year 1991, what is the difference between the Gross enrolment ratio (%) in Pre-primary schools and Gross enrolment ratio (%) in Primary schools?
Your answer should be very brief. -13.28. In the year 1991, what is the difference between the Gross enrolment ratio (%) of Pre-primary schools and Gross enrolment ratio (%) of Secondary schools?
Ensure brevity in your answer.  -2.04. In the year 1991, what is the difference between the Gross enrolment ratio (%) in Pre-primary schools and Gross enrolment ratio (%) in Tertiary schools?
Give a very brief answer. 86.2. In the year 1991, what is the difference between the Gross enrolment ratio (%) in Primary schools and Gross enrolment ratio (%) in Secondary schools?
Keep it short and to the point. 11.24. In the year 1991, what is the difference between the Gross enrolment ratio (%) in Primary schools and Gross enrolment ratio (%) in Tertiary schools?
Your response must be concise. 99.48. In the year 1991, what is the difference between the Gross enrolment ratio (%) of Secondary schools and Gross enrolment ratio (%) of Tertiary schools?
Offer a very short reply. 88.23. In the year 1992, what is the difference between the Gross enrolment ratio (%) in Pre-primary schools and Gross enrolment ratio (%) in Primary schools?
Provide a succinct answer. -14.74. In the year 1992, what is the difference between the Gross enrolment ratio (%) of Pre-primary schools and Gross enrolment ratio (%) of Secondary schools?
Your response must be concise. -6.5. In the year 1992, what is the difference between the Gross enrolment ratio (%) in Pre-primary schools and Gross enrolment ratio (%) in Tertiary schools?
Your response must be concise. 80.88. In the year 1992, what is the difference between the Gross enrolment ratio (%) of Primary schools and Gross enrolment ratio (%) of Secondary schools?
Ensure brevity in your answer.  8.25. In the year 1992, what is the difference between the Gross enrolment ratio (%) in Primary schools and Gross enrolment ratio (%) in Tertiary schools?
Provide a short and direct response. 95.62. In the year 1992, what is the difference between the Gross enrolment ratio (%) of Secondary schools and Gross enrolment ratio (%) of Tertiary schools?
Your response must be concise. 87.38. What is the ratio of the Gross enrolment ratio (%) of Primary schools in 1983 to that in 1985?
Offer a very short reply. 1. What is the ratio of the Gross enrolment ratio (%) in Secondary schools in 1983 to that in 1985?
Make the answer very short. 0.94. What is the ratio of the Gross enrolment ratio (%) of Tertiary schools in 1983 to that in 1985?
Give a very brief answer. 0.92. What is the ratio of the Gross enrolment ratio (%) in Pre-primary schools in 1983 to that in 1986?
Provide a succinct answer. 1.05. What is the ratio of the Gross enrolment ratio (%) of Primary schools in 1983 to that in 1986?
Offer a terse response. 1.03. What is the ratio of the Gross enrolment ratio (%) in Secondary schools in 1983 to that in 1986?
Keep it short and to the point. 0.91. What is the ratio of the Gross enrolment ratio (%) of Tertiary schools in 1983 to that in 1986?
Offer a terse response. 1.14. What is the ratio of the Gross enrolment ratio (%) in Pre-primary schools in 1983 to that in 1987?
Provide a short and direct response. 1.02. What is the ratio of the Gross enrolment ratio (%) in Primary schools in 1983 to that in 1987?
Give a very brief answer. 1.01. What is the ratio of the Gross enrolment ratio (%) of Secondary schools in 1983 to that in 1987?
Your response must be concise. 0.9. What is the ratio of the Gross enrolment ratio (%) of Tertiary schools in 1983 to that in 1987?
Your answer should be compact. 1.23. What is the ratio of the Gross enrolment ratio (%) in Primary schools in 1983 to that in 1988?
Your response must be concise. 1. What is the ratio of the Gross enrolment ratio (%) of Secondary schools in 1983 to that in 1988?
Give a very brief answer. 0.76. What is the ratio of the Gross enrolment ratio (%) of Tertiary schools in 1983 to that in 1988?
Offer a very short reply. 1.14. What is the ratio of the Gross enrolment ratio (%) in Pre-primary schools in 1983 to that in 1991?
Your response must be concise. 0.8. What is the ratio of the Gross enrolment ratio (%) in Primary schools in 1983 to that in 1991?
Provide a succinct answer. 1.03. What is the ratio of the Gross enrolment ratio (%) of Secondary schools in 1983 to that in 1991?
Keep it short and to the point. 0.81. What is the ratio of the Gross enrolment ratio (%) in Tertiary schools in 1983 to that in 1991?
Your response must be concise. 1.09. What is the ratio of the Gross enrolment ratio (%) in Pre-primary schools in 1983 to that in 1992?
Provide a short and direct response. 0.83. What is the ratio of the Gross enrolment ratio (%) in Primary schools in 1983 to that in 1992?
Your response must be concise. 1.05. What is the ratio of the Gross enrolment ratio (%) in Secondary schools in 1983 to that in 1992?
Make the answer very short. 0.8. What is the ratio of the Gross enrolment ratio (%) in Tertiary schools in 1983 to that in 1992?
Your response must be concise. 0.63. What is the ratio of the Gross enrolment ratio (%) of Pre-primary schools in 1985 to that in 1986?
Ensure brevity in your answer.  1.05. What is the ratio of the Gross enrolment ratio (%) in Primary schools in 1985 to that in 1986?
Your answer should be compact. 1.03. What is the ratio of the Gross enrolment ratio (%) in Secondary schools in 1985 to that in 1986?
Ensure brevity in your answer.  0.97. What is the ratio of the Gross enrolment ratio (%) in Tertiary schools in 1985 to that in 1986?
Provide a succinct answer. 1.25. What is the ratio of the Gross enrolment ratio (%) of Pre-primary schools in 1985 to that in 1987?
Your response must be concise. 1.03. What is the ratio of the Gross enrolment ratio (%) of Primary schools in 1985 to that in 1987?
Ensure brevity in your answer.  1.02. What is the ratio of the Gross enrolment ratio (%) in Secondary schools in 1985 to that in 1987?
Your response must be concise. 0.95. What is the ratio of the Gross enrolment ratio (%) of Tertiary schools in 1985 to that in 1987?
Provide a short and direct response. 1.35. What is the ratio of the Gross enrolment ratio (%) in Pre-primary schools in 1985 to that in 1988?
Keep it short and to the point. 1. What is the ratio of the Gross enrolment ratio (%) of Secondary schools in 1985 to that in 1988?
Your answer should be very brief. 0.81. What is the ratio of the Gross enrolment ratio (%) of Tertiary schools in 1985 to that in 1988?
Your response must be concise. 1.24. What is the ratio of the Gross enrolment ratio (%) of Pre-primary schools in 1985 to that in 1991?
Keep it short and to the point. 0.81. What is the ratio of the Gross enrolment ratio (%) of Primary schools in 1985 to that in 1991?
Your answer should be very brief. 1.03. What is the ratio of the Gross enrolment ratio (%) in Secondary schools in 1985 to that in 1991?
Provide a succinct answer. 0.86. What is the ratio of the Gross enrolment ratio (%) of Tertiary schools in 1985 to that in 1991?
Keep it short and to the point. 1.19. What is the ratio of the Gross enrolment ratio (%) in Pre-primary schools in 1985 to that in 1992?
Keep it short and to the point. 0.84. What is the ratio of the Gross enrolment ratio (%) of Primary schools in 1985 to that in 1992?
Make the answer very short. 1.05. What is the ratio of the Gross enrolment ratio (%) in Secondary schools in 1985 to that in 1992?
Your response must be concise. 0.85. What is the ratio of the Gross enrolment ratio (%) in Tertiary schools in 1985 to that in 1992?
Provide a short and direct response. 0.68. What is the ratio of the Gross enrolment ratio (%) in Pre-primary schools in 1986 to that in 1987?
Keep it short and to the point. 0.98. What is the ratio of the Gross enrolment ratio (%) of Secondary schools in 1986 to that in 1987?
Your answer should be compact. 0.98. What is the ratio of the Gross enrolment ratio (%) of Tertiary schools in 1986 to that in 1987?
Your answer should be compact. 1.08. What is the ratio of the Gross enrolment ratio (%) in Pre-primary schools in 1986 to that in 1988?
Make the answer very short. 0.94. What is the ratio of the Gross enrolment ratio (%) of Primary schools in 1986 to that in 1988?
Give a very brief answer. 0.98. What is the ratio of the Gross enrolment ratio (%) in Secondary schools in 1986 to that in 1988?
Give a very brief answer. 0.84. What is the ratio of the Gross enrolment ratio (%) in Tertiary schools in 1986 to that in 1988?
Your response must be concise. 1. What is the ratio of the Gross enrolment ratio (%) in Pre-primary schools in 1986 to that in 1991?
Give a very brief answer. 0.77. What is the ratio of the Gross enrolment ratio (%) of Primary schools in 1986 to that in 1991?
Offer a terse response. 1. What is the ratio of the Gross enrolment ratio (%) in Secondary schools in 1986 to that in 1991?
Your response must be concise. 0.89. What is the ratio of the Gross enrolment ratio (%) of Tertiary schools in 1986 to that in 1991?
Offer a terse response. 0.95. What is the ratio of the Gross enrolment ratio (%) of Pre-primary schools in 1986 to that in 1992?
Provide a short and direct response. 0.8. What is the ratio of the Gross enrolment ratio (%) in Primary schools in 1986 to that in 1992?
Your response must be concise. 1.02. What is the ratio of the Gross enrolment ratio (%) in Secondary schools in 1986 to that in 1992?
Provide a succinct answer. 0.88. What is the ratio of the Gross enrolment ratio (%) in Tertiary schools in 1986 to that in 1992?
Offer a very short reply. 0.55. What is the ratio of the Gross enrolment ratio (%) of Pre-primary schools in 1987 to that in 1988?
Offer a very short reply. 0.97. What is the ratio of the Gross enrolment ratio (%) of Primary schools in 1987 to that in 1988?
Offer a very short reply. 0.99. What is the ratio of the Gross enrolment ratio (%) of Secondary schools in 1987 to that in 1988?
Your response must be concise. 0.85. What is the ratio of the Gross enrolment ratio (%) in Tertiary schools in 1987 to that in 1988?
Give a very brief answer. 0.92. What is the ratio of the Gross enrolment ratio (%) of Pre-primary schools in 1987 to that in 1991?
Offer a very short reply. 0.79. What is the ratio of the Gross enrolment ratio (%) of Primary schools in 1987 to that in 1991?
Make the answer very short. 1.02. What is the ratio of the Gross enrolment ratio (%) of Secondary schools in 1987 to that in 1991?
Provide a succinct answer. 0.91. What is the ratio of the Gross enrolment ratio (%) of Tertiary schools in 1987 to that in 1991?
Keep it short and to the point. 0.88. What is the ratio of the Gross enrolment ratio (%) of Pre-primary schools in 1987 to that in 1992?
Your response must be concise. 0.82. What is the ratio of the Gross enrolment ratio (%) in Primary schools in 1987 to that in 1992?
Your answer should be compact. 1.03. What is the ratio of the Gross enrolment ratio (%) of Secondary schools in 1987 to that in 1992?
Keep it short and to the point. 0.89. What is the ratio of the Gross enrolment ratio (%) in Tertiary schools in 1987 to that in 1992?
Your answer should be compact. 0.51. What is the ratio of the Gross enrolment ratio (%) in Pre-primary schools in 1988 to that in 1991?
Make the answer very short. 0.81. What is the ratio of the Gross enrolment ratio (%) in Primary schools in 1988 to that in 1991?
Provide a short and direct response. 1.03. What is the ratio of the Gross enrolment ratio (%) of Secondary schools in 1988 to that in 1991?
Your response must be concise. 1.06. What is the ratio of the Gross enrolment ratio (%) in Tertiary schools in 1988 to that in 1991?
Keep it short and to the point. 0.96. What is the ratio of the Gross enrolment ratio (%) of Pre-primary schools in 1988 to that in 1992?
Your answer should be compact. 0.84. What is the ratio of the Gross enrolment ratio (%) in Primary schools in 1988 to that in 1992?
Your answer should be very brief. 1.05. What is the ratio of the Gross enrolment ratio (%) of Secondary schools in 1988 to that in 1992?
Make the answer very short. 1.05. What is the ratio of the Gross enrolment ratio (%) of Tertiary schools in 1988 to that in 1992?
Offer a very short reply. 0.55. What is the ratio of the Gross enrolment ratio (%) of Pre-primary schools in 1991 to that in 1992?
Your answer should be compact. 1.04. What is the ratio of the Gross enrolment ratio (%) in Primary schools in 1991 to that in 1992?
Offer a very short reply. 1.02. What is the ratio of the Gross enrolment ratio (%) of Tertiary schools in 1991 to that in 1992?
Provide a succinct answer. 0.58. What is the difference between the highest and the second highest Gross enrolment ratio (%) of Pre-primary schools?
Provide a short and direct response. 3.17. What is the difference between the highest and the second highest Gross enrolment ratio (%) in Primary schools?
Offer a terse response. 0.2. What is the difference between the highest and the second highest Gross enrolment ratio (%) of Secondary schools?
Your response must be concise. 4.27. What is the difference between the highest and the second highest Gross enrolment ratio (%) of Tertiary schools?
Provide a short and direct response. 1.6. What is the difference between the highest and the lowest Gross enrolment ratio (%) in Pre-primary schools?
Give a very brief answer. 20.65. What is the difference between the highest and the lowest Gross enrolment ratio (%) of Primary schools?
Ensure brevity in your answer.  5.07. What is the difference between the highest and the lowest Gross enrolment ratio (%) in Secondary schools?
Provide a succinct answer. 22.85. What is the difference between the highest and the lowest Gross enrolment ratio (%) of Tertiary schools?
Ensure brevity in your answer.  2.49. 